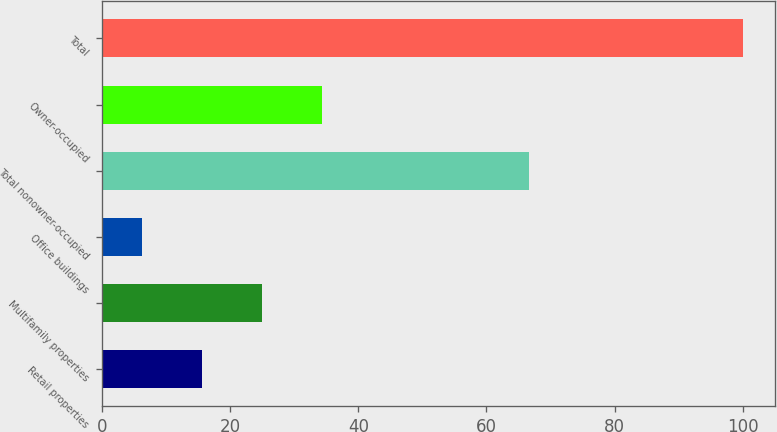Convert chart. <chart><loc_0><loc_0><loc_500><loc_500><bar_chart><fcel>Retail properties<fcel>Multifamily properties<fcel>Office buildings<fcel>Total nonowner-occupied<fcel>Owner-occupied<fcel>Total<nl><fcel>15.67<fcel>25.04<fcel>6.3<fcel>66.6<fcel>34.41<fcel>100<nl></chart> 